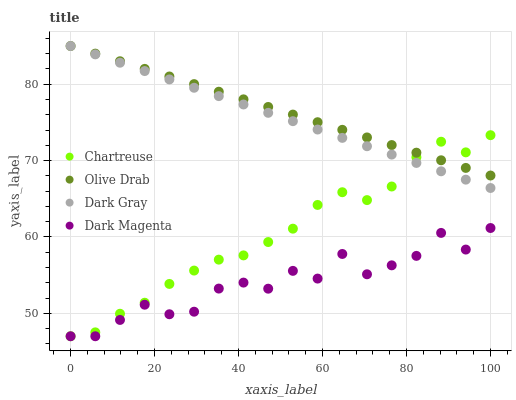Does Dark Magenta have the minimum area under the curve?
Answer yes or no. Yes. Does Olive Drab have the maximum area under the curve?
Answer yes or no. Yes. Does Chartreuse have the minimum area under the curve?
Answer yes or no. No. Does Chartreuse have the maximum area under the curve?
Answer yes or no. No. Is Olive Drab the smoothest?
Answer yes or no. Yes. Is Dark Magenta the roughest?
Answer yes or no. Yes. Is Chartreuse the smoothest?
Answer yes or no. No. Is Chartreuse the roughest?
Answer yes or no. No. Does Chartreuse have the lowest value?
Answer yes or no. Yes. Does Olive Drab have the lowest value?
Answer yes or no. No. Does Olive Drab have the highest value?
Answer yes or no. Yes. Does Chartreuse have the highest value?
Answer yes or no. No. Is Dark Magenta less than Dark Gray?
Answer yes or no. Yes. Is Dark Gray greater than Dark Magenta?
Answer yes or no. Yes. Does Chartreuse intersect Dark Gray?
Answer yes or no. Yes. Is Chartreuse less than Dark Gray?
Answer yes or no. No. Is Chartreuse greater than Dark Gray?
Answer yes or no. No. Does Dark Magenta intersect Dark Gray?
Answer yes or no. No. 